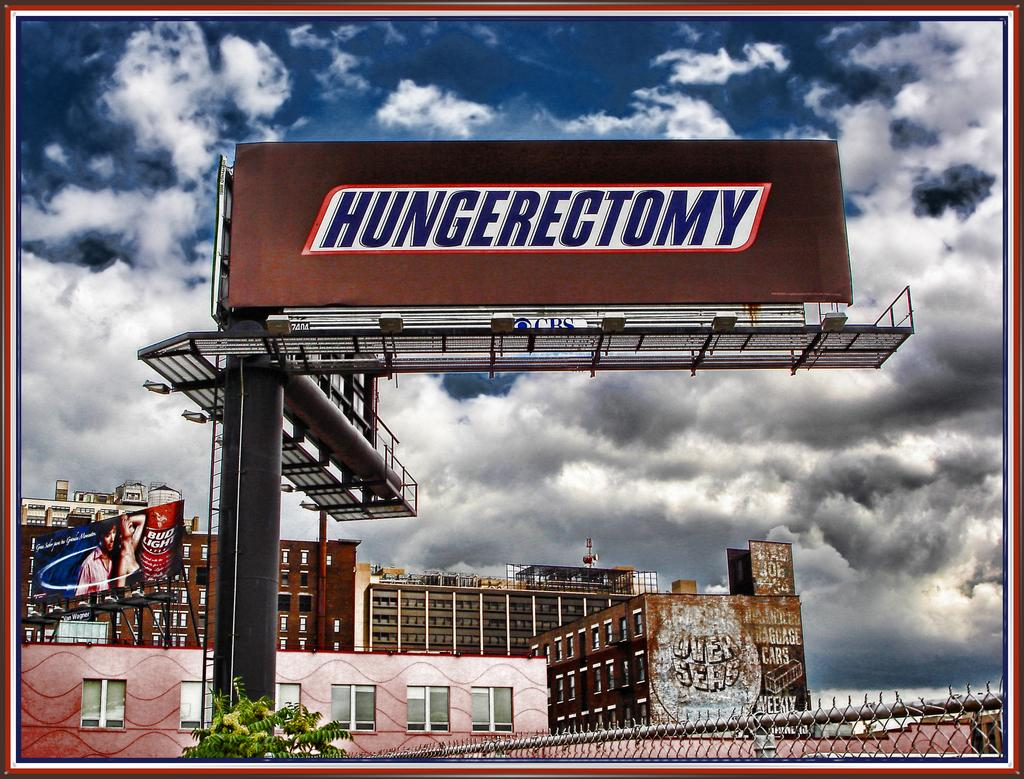Provide a one-sentence caption for the provided image. A billboard that says Hungerectomy on it like a Snickers wrapper. 